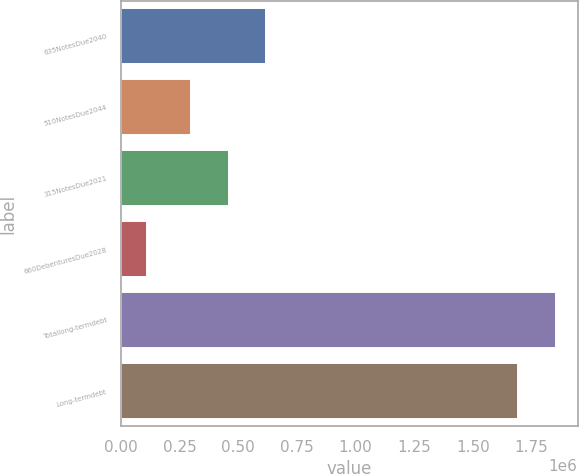Convert chart to OTSL. <chart><loc_0><loc_0><loc_500><loc_500><bar_chart><fcel>635NotesDue2040<fcel>510NotesDue2044<fcel>315NotesDue2021<fcel>660DebenturesDue2028<fcel>Totallong-termdebt<fcel>Long-termdebt<nl><fcel>620000<fcel>300000<fcel>460000<fcel>109895<fcel>1.85361e+06<fcel>1.69361e+06<nl></chart> 